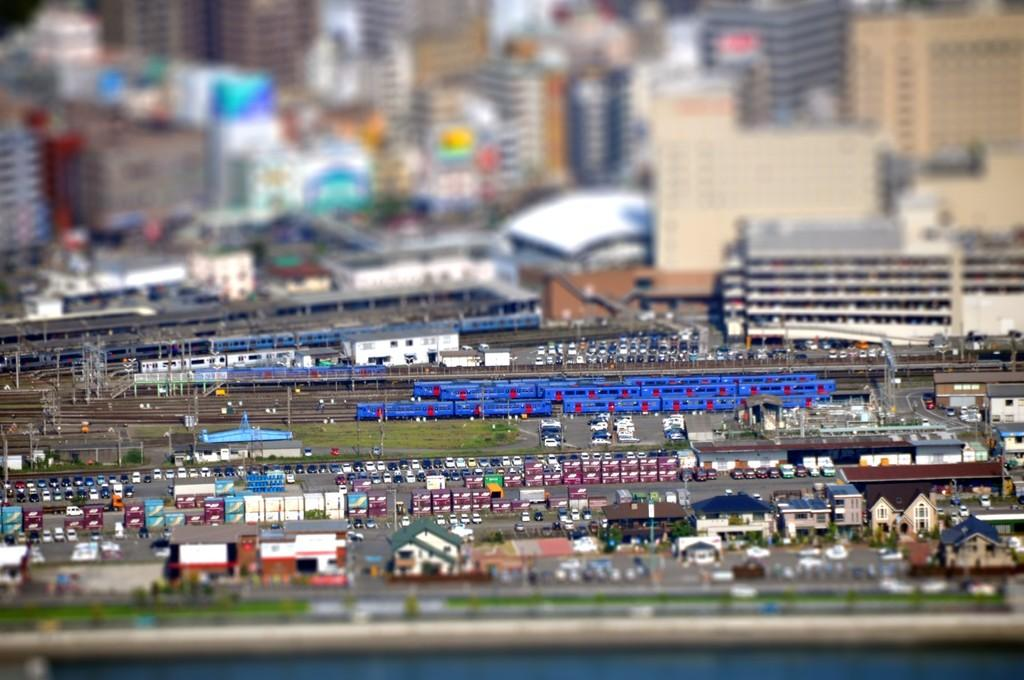What is the person in the image holding? The person in the image is holding a phone. Can you describe the background of the image? There is a clock on the wall in the background of the image. What type of health benefits can be gained from the phone in the image? The image does not provide information about health benefits related to the phone. 